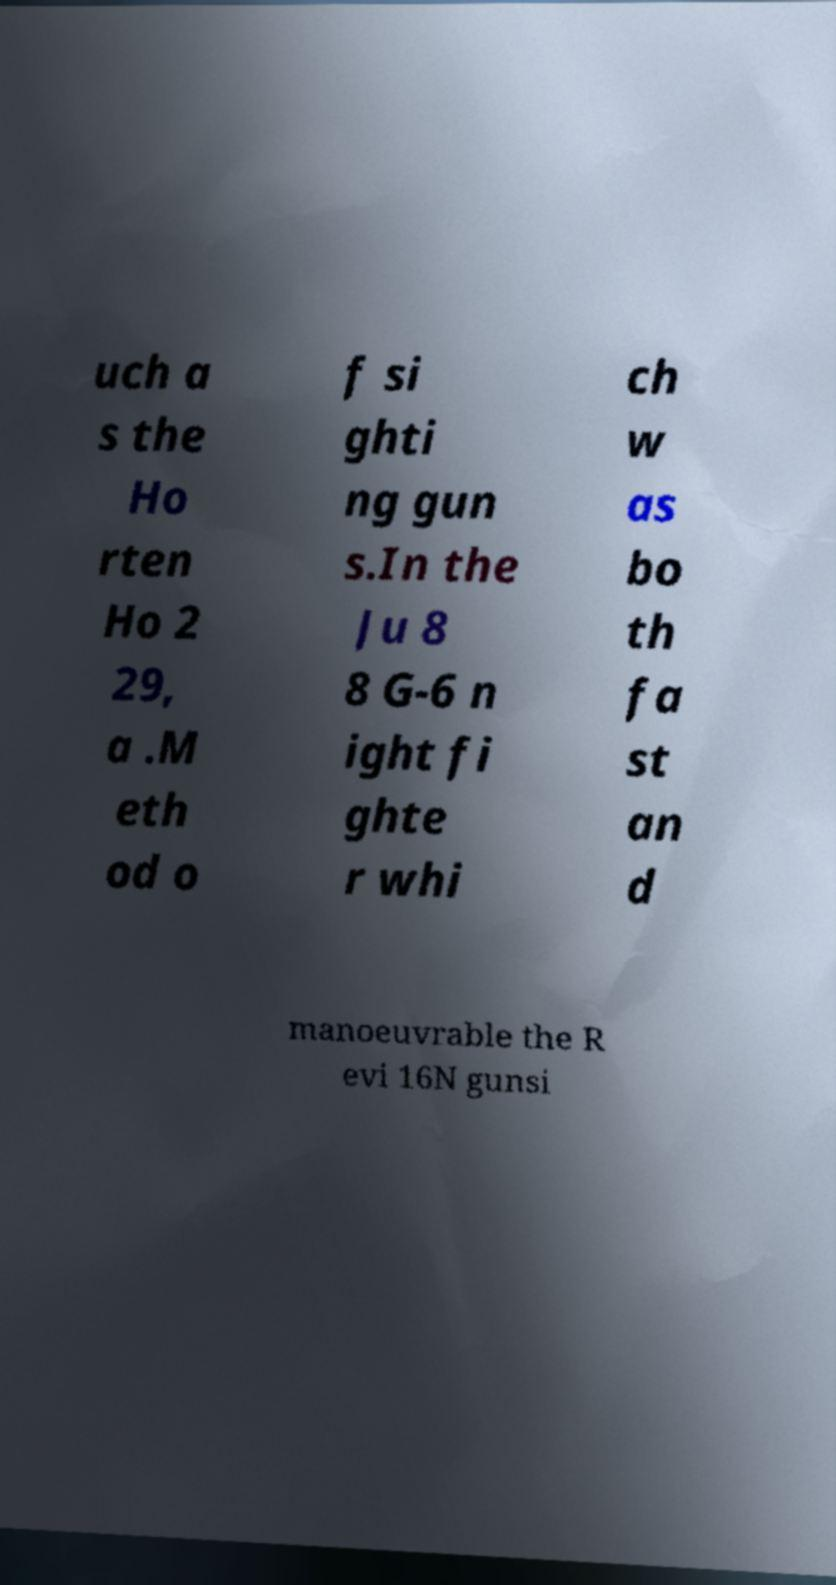Could you assist in decoding the text presented in this image and type it out clearly? uch a s the Ho rten Ho 2 29, a .M eth od o f si ghti ng gun s.In the Ju 8 8 G-6 n ight fi ghte r whi ch w as bo th fa st an d manoeuvrable the R evi 16N gunsi 